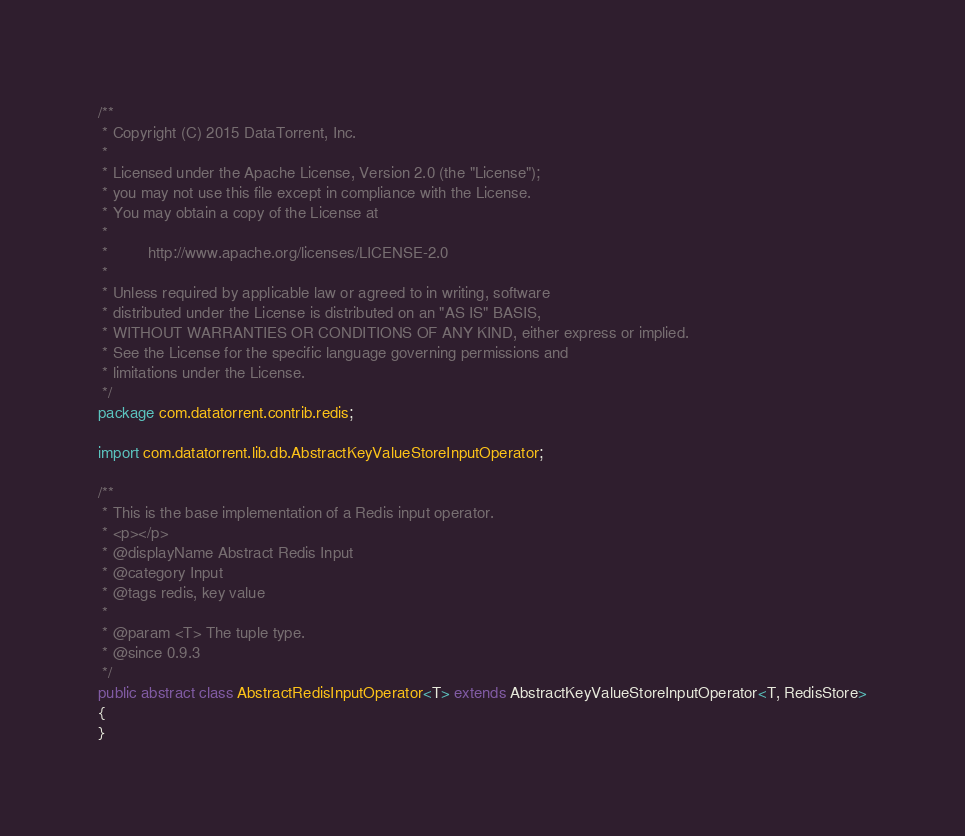<code> <loc_0><loc_0><loc_500><loc_500><_Java_>/**
 * Copyright (C) 2015 DataTorrent, Inc.
 *
 * Licensed under the Apache License, Version 2.0 (the "License");
 * you may not use this file except in compliance with the License.
 * You may obtain a copy of the License at
 *
 *         http://www.apache.org/licenses/LICENSE-2.0
 *
 * Unless required by applicable law or agreed to in writing, software
 * distributed under the License is distributed on an "AS IS" BASIS,
 * WITHOUT WARRANTIES OR CONDITIONS OF ANY KIND, either express or implied.
 * See the License for the specific language governing permissions and
 * limitations under the License.
 */
package com.datatorrent.contrib.redis;

import com.datatorrent.lib.db.AbstractKeyValueStoreInputOperator;

/**
 * This is the base implementation of a Redis input operator.
 * <p></p>
 * @displayName Abstract Redis Input
 * @category Input
 * @tags redis, key value
 *
 * @param <T> The tuple type.
 * @since 0.9.3
 */
public abstract class AbstractRedisInputOperator<T> extends AbstractKeyValueStoreInputOperator<T, RedisStore>
{
}
</code> 